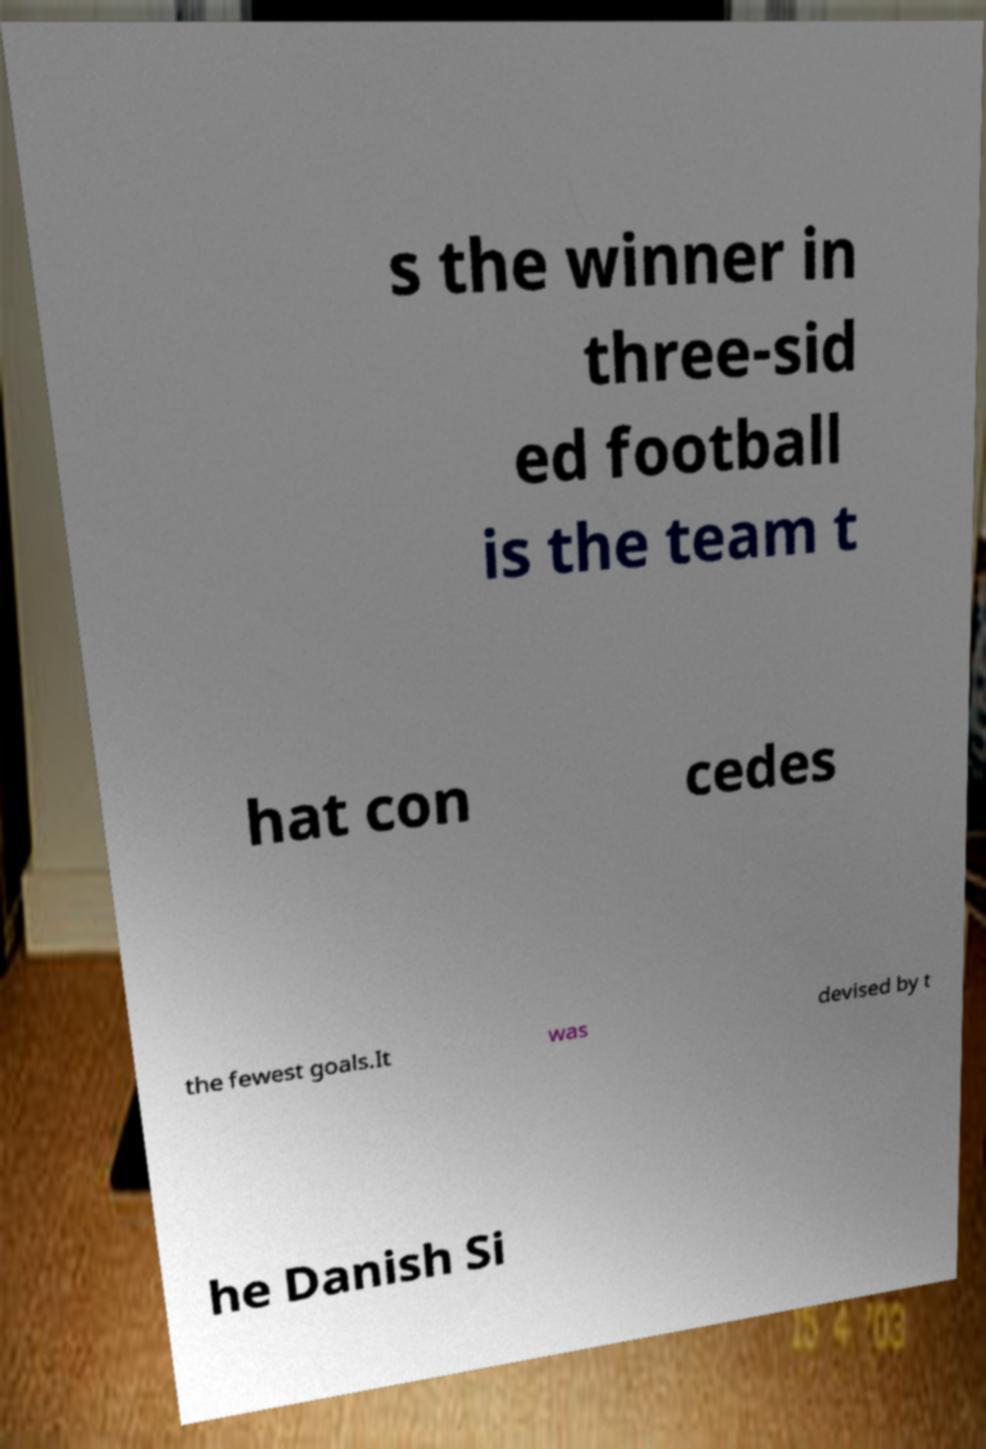I need the written content from this picture converted into text. Can you do that? s the winner in three-sid ed football is the team t hat con cedes the fewest goals.It was devised by t he Danish Si 